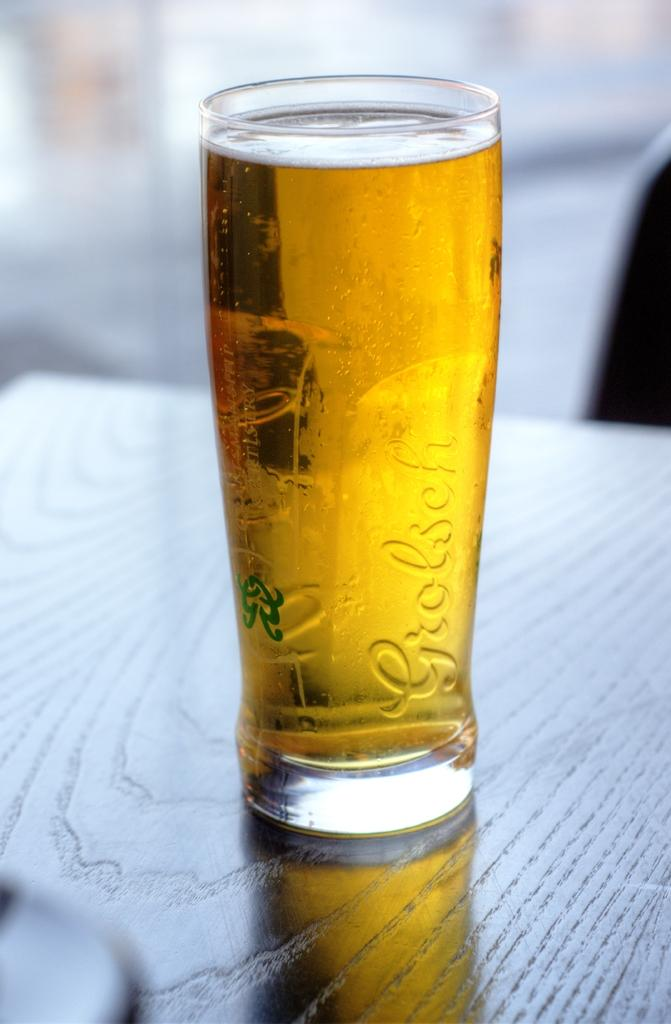<image>
Write a terse but informative summary of the picture. A glass of amber liquid has the word Grolsch on it. 